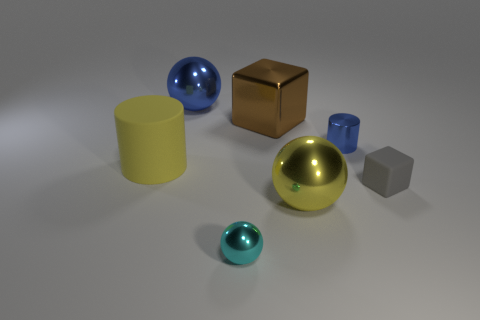There is a cylinder that is left of the tiny blue metallic cylinder; is it the same color as the big shiny thing that is in front of the tiny matte object?
Your response must be concise. Yes. Are there any other big yellow cylinders made of the same material as the yellow cylinder?
Provide a short and direct response. No. Is the material of the large yellow object to the left of the large yellow metallic thing the same as the tiny block?
Give a very brief answer. Yes. There is a object that is left of the large brown shiny block and in front of the big matte object; how big is it?
Provide a short and direct response. Small. The large matte object has what color?
Provide a short and direct response. Yellow. How many big spheres are there?
Offer a terse response. 2. How many large metal balls are the same color as the metallic cylinder?
Offer a very short reply. 1. Is the shape of the yellow object that is in front of the gray block the same as the tiny shiny object on the left side of the yellow ball?
Keep it short and to the point. Yes. The big shiny ball behind the tiny shiny thing that is behind the big yellow object behind the gray rubber thing is what color?
Make the answer very short. Blue. What color is the small cylinder right of the cyan metal sphere?
Ensure brevity in your answer.  Blue. 